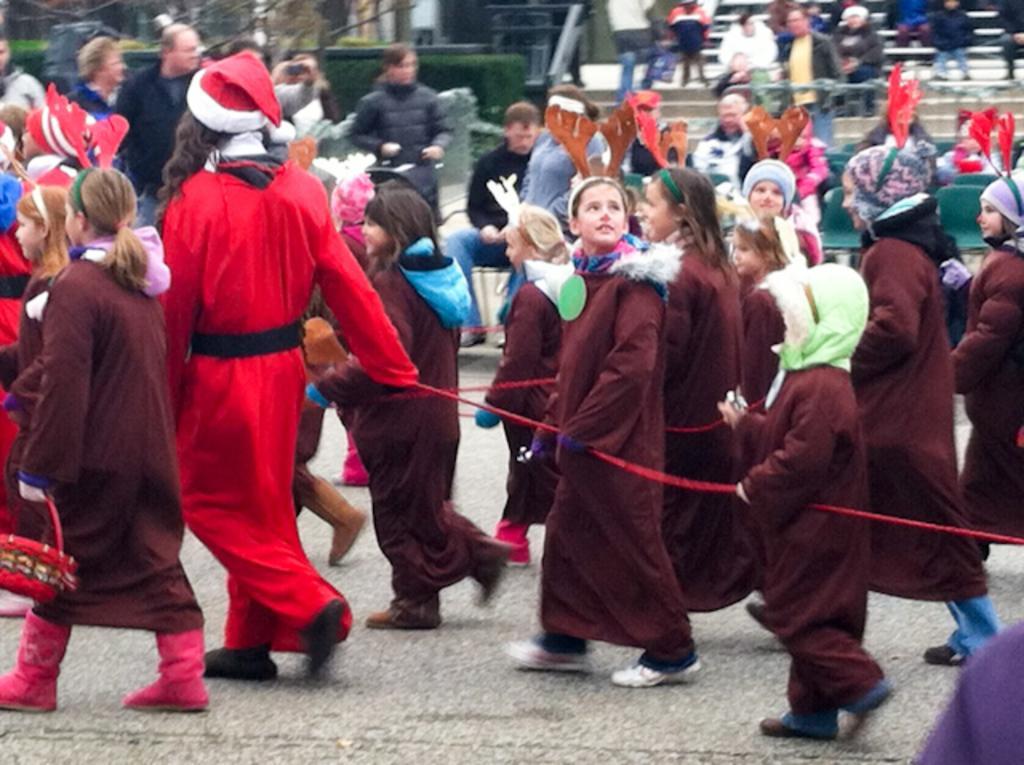Describe this image in one or two sentences. In this image we can see the people and also the kids walking on the road. We can also see the rope, stairs, trees and also the plants. We can also see the people wearing the caps. 